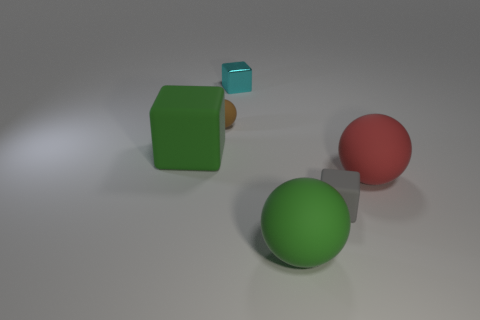Subtract all large rubber balls. How many balls are left? 1 Add 3 tiny metallic things. How many objects exist? 9 Subtract all gray balls. Subtract all red cylinders. How many balls are left? 3 Subtract all tiny yellow metallic objects. Subtract all brown matte things. How many objects are left? 5 Add 4 small cyan blocks. How many small cyan blocks are left? 5 Add 3 big metal blocks. How many big metal blocks exist? 3 Subtract 0 green cylinders. How many objects are left? 6 